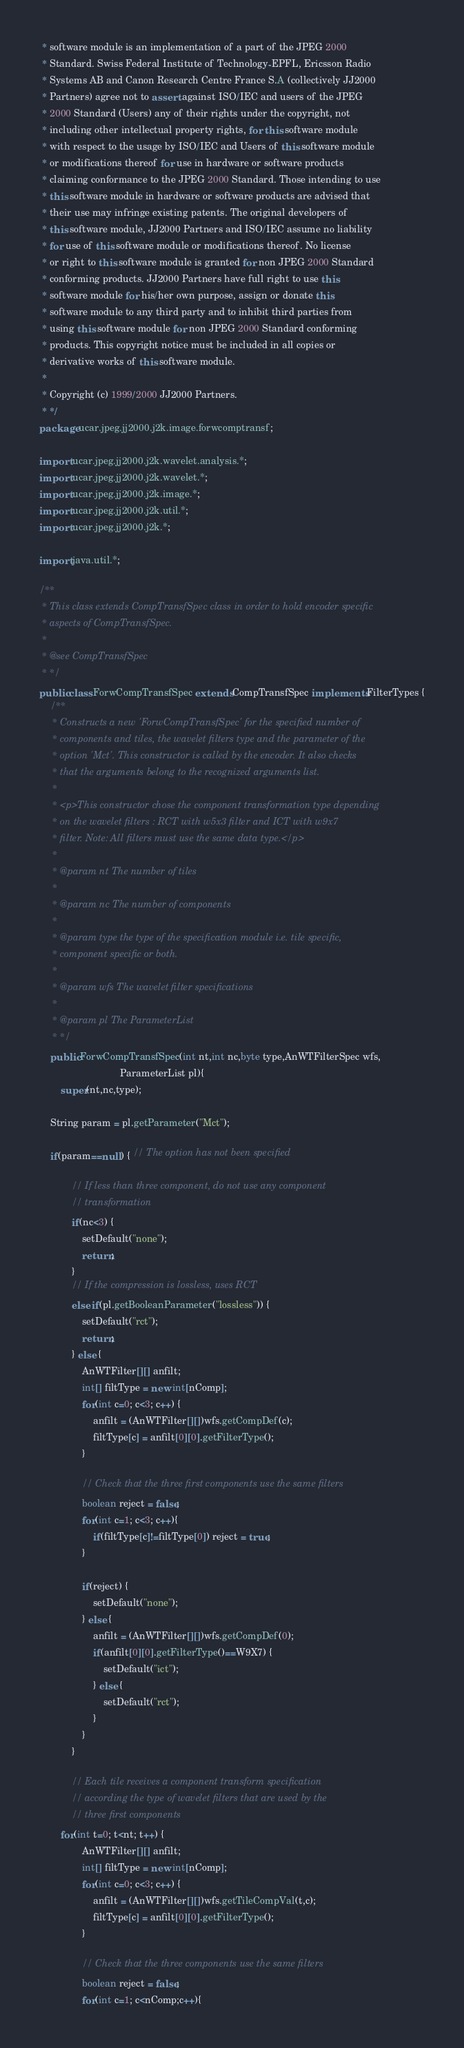<code> <loc_0><loc_0><loc_500><loc_500><_Java_> * software module is an implementation of a part of the JPEG 2000
 * Standard. Swiss Federal Institute of Technology-EPFL, Ericsson Radio
 * Systems AB and Canon Research Centre France S.A (collectively JJ2000
 * Partners) agree not to assert against ISO/IEC and users of the JPEG
 * 2000 Standard (Users) any of their rights under the copyright, not
 * including other intellectual property rights, for this software module
 * with respect to the usage by ISO/IEC and Users of this software module
 * or modifications thereof for use in hardware or software products
 * claiming conformance to the JPEG 2000 Standard. Those intending to use
 * this software module in hardware or software products are advised that
 * their use may infringe existing patents. The original developers of
 * this software module, JJ2000 Partners and ISO/IEC assume no liability
 * for use of this software module or modifications thereof. No license
 * or right to this software module is granted for non JPEG 2000 Standard
 * conforming products. JJ2000 Partners have full right to use this
 * software module for his/her own purpose, assign or donate this
 * software module to any third party and to inhibit third parties from
 * using this software module for non JPEG 2000 Standard conforming
 * products. This copyright notice must be included in all copies or
 * derivative works of this software module.
 * 
 * Copyright (c) 1999/2000 JJ2000 Partners.
 * */
package ucar.jpeg.jj2000.j2k.image.forwcomptransf;

import ucar.jpeg.jj2000.j2k.wavelet.analysis.*;
import ucar.jpeg.jj2000.j2k.wavelet.*;
import ucar.jpeg.jj2000.j2k.image.*;
import ucar.jpeg.jj2000.j2k.util.*;
import ucar.jpeg.jj2000.j2k.*;

import java.util.*;

/**
 * This class extends CompTransfSpec class in order to hold encoder specific
 * aspects of CompTransfSpec.
 *
 * @see CompTransfSpec
 * */
public class ForwCompTransfSpec extends CompTransfSpec implements FilterTypes {
    /**
     * Constructs a new 'ForwCompTransfSpec' for the specified number of
     * components and tiles, the wavelet filters type and the parameter of the
     * option 'Mct'. This constructor is called by the encoder. It also checks
     * that the arguments belong to the recognized arguments list.
     *
     * <p>This constructor chose the component transformation type depending
     * on the wavelet filters : RCT with w5x3 filter and ICT with w9x7
     * filter. Note: All filters must use the same data type.</p>
     *
     * @param nt The number of tiles
     *
     * @param nc The number of components
     *
     * @param type the type of the specification module i.e. tile specific,
     * component specific or both.
     *
     * @param wfs The wavelet filter specifications
     *
     * @param pl The ParameterList
     * */
    public ForwCompTransfSpec(int nt,int nc,byte type,AnWTFilterSpec wfs,
                              ParameterList pl){
        super(nt,nc,type);

	String param = pl.getParameter("Mct");

	if(param==null) { // The option has not been specified
            
            // If less than three component, do not use any component
            // transformation 
            if(nc<3) {
                setDefault("none");
                return;
            }
            // If the compression is lossless, uses RCT
            else if(pl.getBooleanParameter("lossless")) {
                setDefault("rct");
                return;
            } else { 
                AnWTFilter[][] anfilt;
                int[] filtType = new int[nComp];
                for(int c=0; c<3; c++) {
                    anfilt = (AnWTFilter[][])wfs.getCompDef(c);
                    filtType[c] = anfilt[0][0].getFilterType();
                }

                // Check that the three first components use the same filters
                boolean reject = false;
                for(int c=1; c<3; c++){
                    if(filtType[c]!=filtType[0]) reject = true;
                }
                
                if(reject) {
                    setDefault("none");
                } else {
                    anfilt = (AnWTFilter[][])wfs.getCompDef(0);
                    if(anfilt[0][0].getFilterType()==W9X7) {
                        setDefault("ict");
                    } else {
                        setDefault("rct");
                    }
                }
            }

            // Each tile receives a component transform specification
            // according the type of wavelet filters that are used by the
            // three first components
 	    for(int t=0; t<nt; t++) {
                AnWTFilter[][] anfilt;
                int[] filtType = new int[nComp];
                for(int c=0; c<3; c++) {
                    anfilt = (AnWTFilter[][])wfs.getTileCompVal(t,c);
                    filtType[c] = anfilt[0][0].getFilterType();
                }
                
                // Check that the three components use the same filters
                boolean reject = false;
                for(int c=1; c<nComp;c++){</code> 